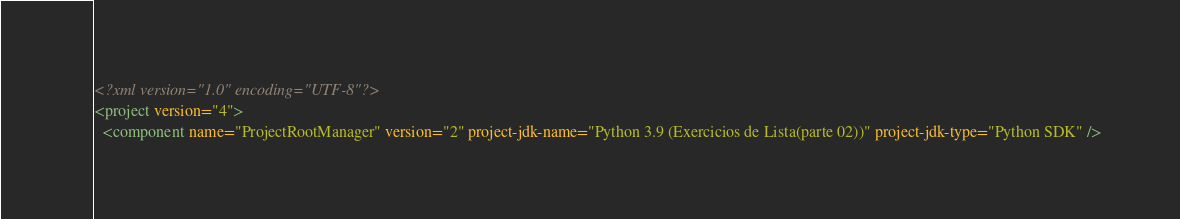<code> <loc_0><loc_0><loc_500><loc_500><_XML_><?xml version="1.0" encoding="UTF-8"?>
<project version="4">
  <component name="ProjectRootManager" version="2" project-jdk-name="Python 3.9 (Exercicios de Lista(parte 02))" project-jdk-type="Python SDK" /></code> 